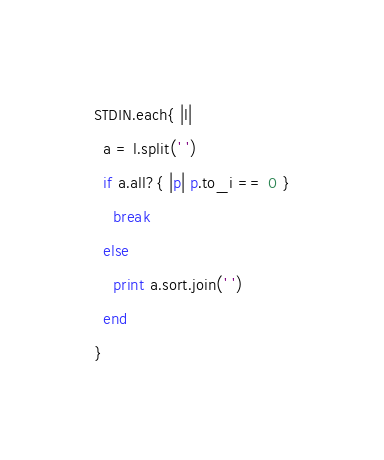<code> <loc_0><loc_0><loc_500><loc_500><_Ruby_>STDIN.each{ |l|
  a = l.split(' ')
  if a.all?{ |p| p.to_i == 0 }
    break
  else
    print a.sort.join(' ')
  end
}</code> 